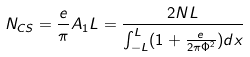Convert formula to latex. <formula><loc_0><loc_0><loc_500><loc_500>N _ { C S } = \frac { e } { \pi } A _ { 1 } L = \frac { 2 N L } { \int _ { - L } ^ { L } ( 1 + \frac { e } { 2 \pi \Phi ^ { 2 } } ) d x }</formula> 